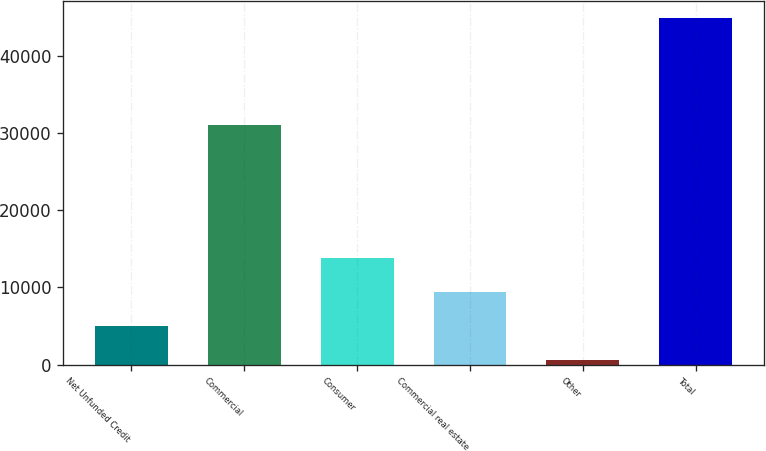Convert chart. <chart><loc_0><loc_0><loc_500><loc_500><bar_chart><fcel>Net Unfunded Credit<fcel>Commercial<fcel>Consumer<fcel>Commercial real estate<fcel>Other<fcel>Total<nl><fcel>5004.6<fcel>31009<fcel>13855.8<fcel>9430.2<fcel>579<fcel>44835<nl></chart> 